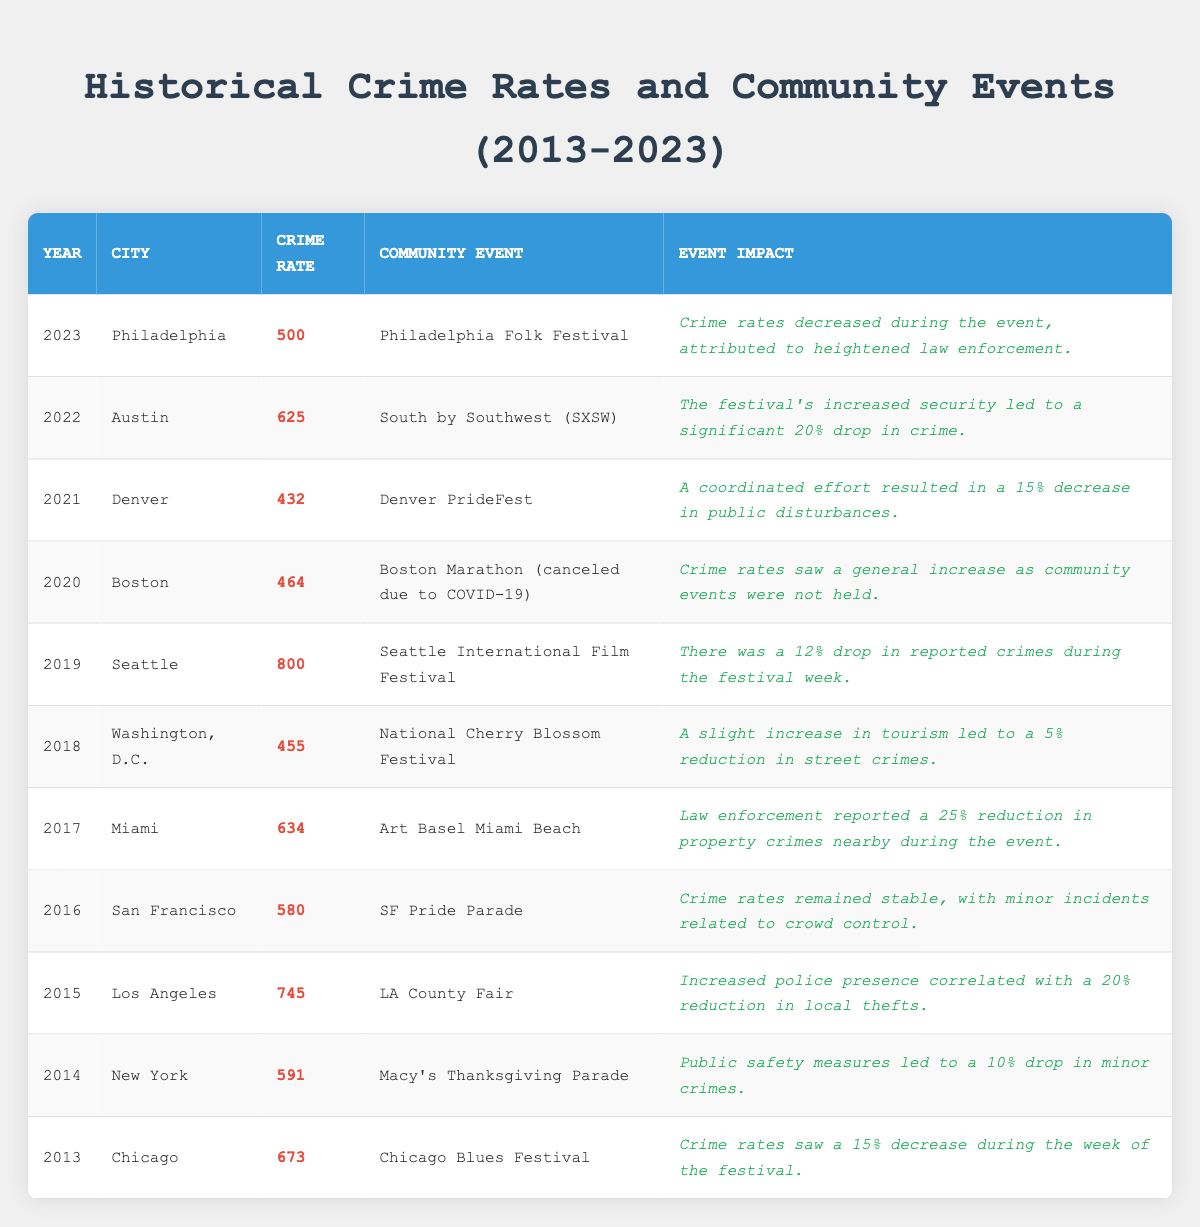What was the crime rate in Los Angeles in 2015? The table lists the crime rate for Los Angeles in 2015 as 745.
Answer: 745 Which event led to a 25% reduction in property crimes in Miami? The table indicates that the Art Basel Miami Beach event in 2017 led to a 25% reduction in property crimes.
Answer: Art Basel Miami Beach What was the crime rate in Chicago during the Chicago Blues Festival in 2013? According to the table, the crime rate in Chicago during the festival in 2013 was 673.
Answer: 673 Did the Boston Marathon in 2020 have an impact on crime rates, and what was it? The table notes that the Boston Marathon was canceled in 2020, resulting in a general increase in crime rates.
Answer: Yes, crime rates increased Which year had the lowest crime rate and what was the rate? By examining the table, the year with the lowest crime rate was 2021 in Denver with a rate of 432.
Answer: 432 What was the event impact reported for the SF Pride Parade in 2016? The table states that crime rates remained stable during the SF Pride Parade in 2016, with only minor incidents related to crowd control.
Answer: Stable crime rates What is the average crime rate from 2013 to 2023 based on the data provided? First, sum the crime rates: (673 + 591 + 745 + 580 + 634 + 455 + 800 + 464 + 625 + 432 + 500) = 6,339. There are 11 data points, so the average is 6,339 / 11 = 576.27.
Answer: 576.27 Which city experienced a 20% drop in crime during South by Southwest (SXSW) in 2022? The table shows that Austin itself experienced a significant 20% drop in crime during the SXSW event.
Answer: Austin Was there an increase or decrease in street crimes during the National Cherry Blossom Festival in 2018? The table mentions a slight increase in tourism leading to a 5% reduction in street crimes during the National Cherry Blossom Festival in 2018.
Answer: Decrease How did the overall crime rates change when community events were not held in 2020? It is noted in the table that crime rates increased due to the absence of community events in 2020.
Answer: Increased Which year had the highest crime rate, and what was the rate? The table indicates that 2019 had the highest crime rate at 800 in Seattle.
Answer: 800 